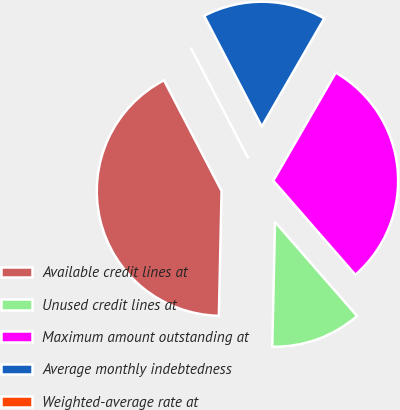Convert chart. <chart><loc_0><loc_0><loc_500><loc_500><pie_chart><fcel>Available credit lines at<fcel>Unused credit lines at<fcel>Maximum amount outstanding at<fcel>Average monthly indebtedness<fcel>Weighted-average rate at<nl><fcel>42.02%<fcel>11.76%<fcel>30.25%<fcel>15.97%<fcel>0.0%<nl></chart> 